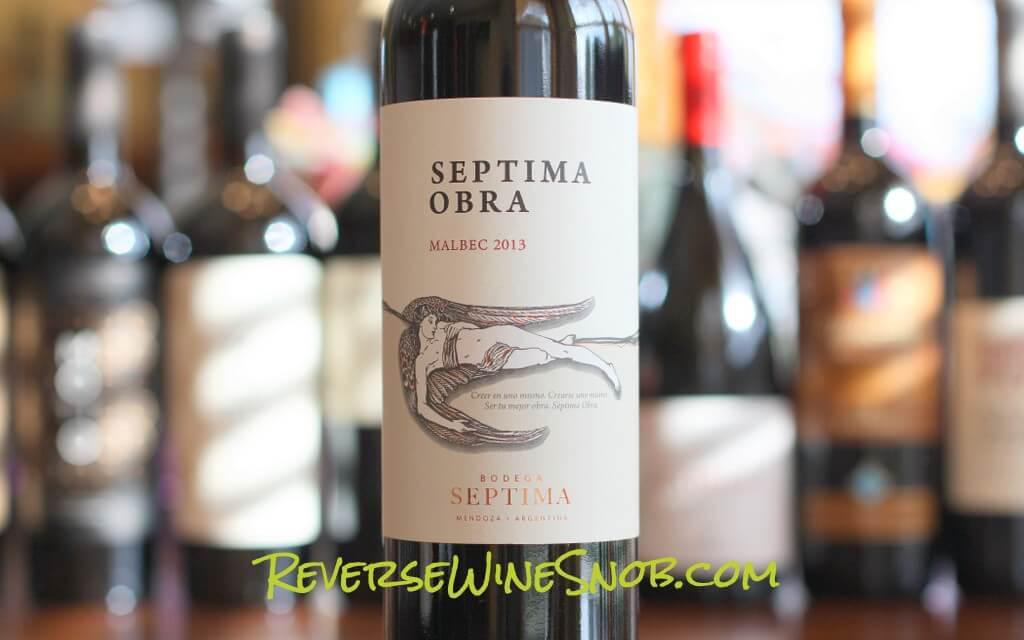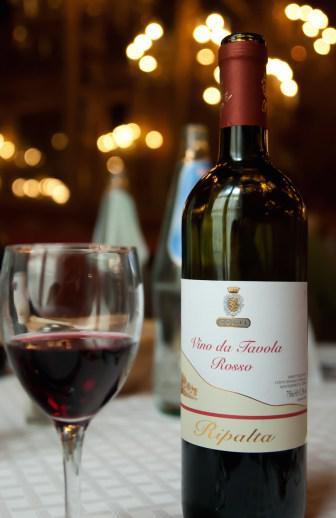The first image is the image on the left, the second image is the image on the right. Assess this claim about the two images: "An image shows wine bottle, glass, grapes and green leaves.". Correct or not? Answer yes or no. No. 